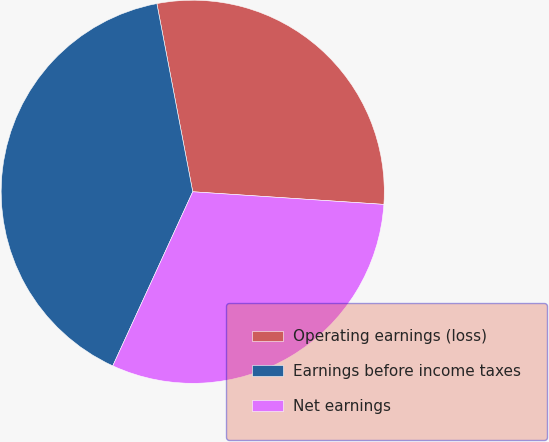<chart> <loc_0><loc_0><loc_500><loc_500><pie_chart><fcel>Operating earnings (loss)<fcel>Earnings before income taxes<fcel>Net earnings<nl><fcel>29.05%<fcel>40.15%<fcel>30.8%<nl></chart> 